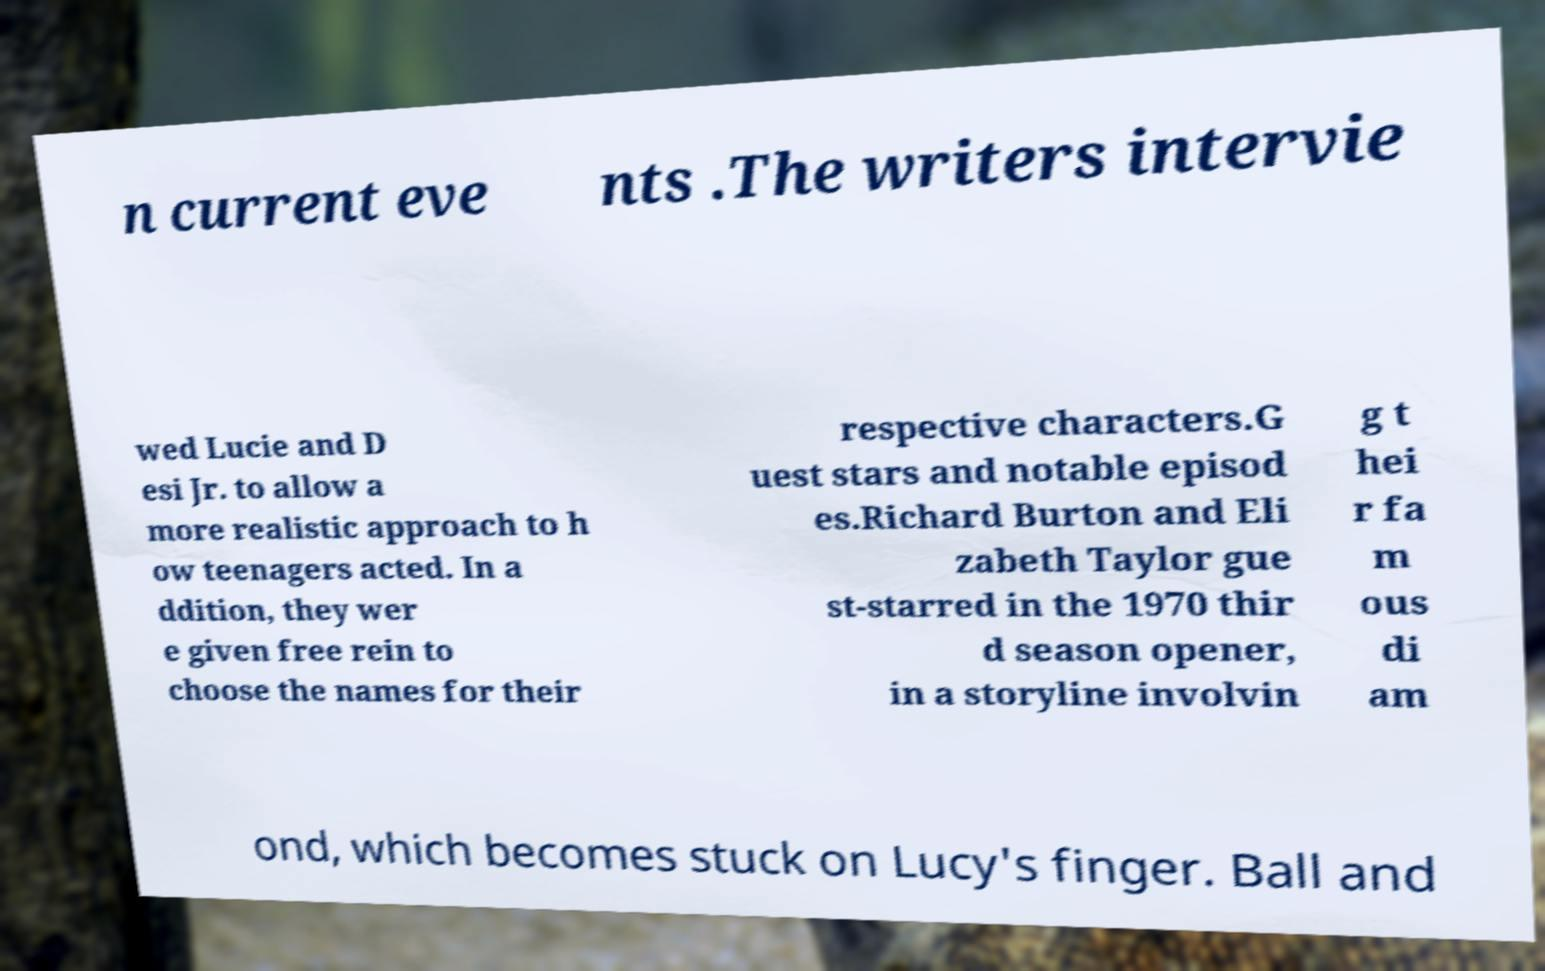For documentation purposes, I need the text within this image transcribed. Could you provide that? n current eve nts .The writers intervie wed Lucie and D esi Jr. to allow a more realistic approach to h ow teenagers acted. In a ddition, they wer e given free rein to choose the names for their respective characters.G uest stars and notable episod es.Richard Burton and Eli zabeth Taylor gue st-starred in the 1970 thir d season opener, in a storyline involvin g t hei r fa m ous di am ond, which becomes stuck on Lucy's finger. Ball and 